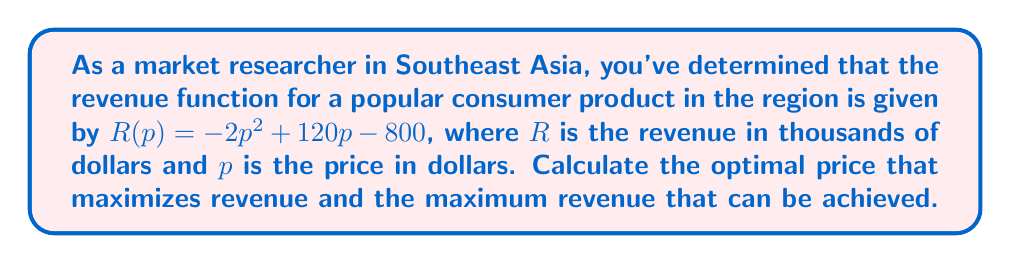Solve this math problem. To find the optimal price that maximizes revenue, we need to find the vertex of the quadratic revenue function. The steps are as follows:

1) The revenue function is in the form of a quadratic equation:
   $R(p) = -2p^2 + 120p - 800$

2) For a quadratic function in the form $f(x) = ax^2 + bx + c$, the x-coordinate of the vertex is given by $x = -\frac{b}{2a}$

3) In our case, $a = -2$ and $b = 120$. Let's substitute these values:

   $p = -\frac{120}{2(-2)} = -\frac{120}{-4} = 30$

4) Therefore, the optimal price is $30 dollars.

5) To find the maximum revenue, we substitute this price back into the original function:

   $R(30) = -2(30)^2 + 120(30) - 800$
   $= -2(900) + 3600 - 800$
   $= -1800 + 3600 - 800$
   $= 1000$

6) The maximum revenue is 1000 thousand dollars, or $1,000,000.

To verify this is indeed a maximum (not a minimum), we can check that $a < 0$ in the original quadratic function, which it is ($a = -2$).
Answer: The optimal price is $30 dollars, and the maximum revenue is $1,000,000. 